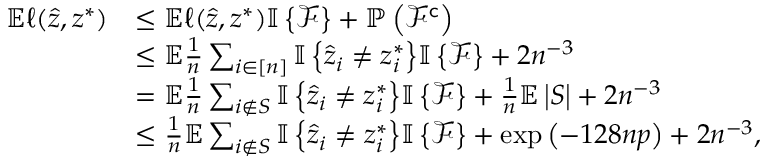Convert formula to latex. <formula><loc_0><loc_0><loc_500><loc_500>\begin{array} { r l } { \mathbb { E } \ell ( \hat { z } , z ^ { * } ) } & { \leq \mathbb { E } \ell ( \hat { z } , z ^ { * } ) { \mathbb { I } \left \{ { \mathcal { F } } \right \} } + \mathbb { P } \left ( \mathcal { F } ^ { c } \right ) } \\ & { \leq \mathbb { E } \frac { 1 } { n } \sum _ { i \in [ n ] } { \mathbb { I } \left \{ { \hat { z } _ { i } \neq z _ { i } ^ { * } } \right \} } { \mathbb { I } \left \{ { \mathcal { F } } \right \} } + 2 n ^ { - 3 } } \\ & { = \mathbb { E } \frac { 1 } { n } \sum _ { i \notin S } { \mathbb { I } \left \{ { \hat { z } _ { i } \neq z _ { i } ^ { * } } \right \} } { \mathbb { I } \left \{ { \mathcal { F } } \right \} } + \frac { 1 } { n } \mathbb { E } \left | S \right | + 2 n ^ { - 3 } } \\ & { \leq \frac { 1 } { n } \mathbb { E } \sum _ { i \notin S } { \mathbb { I } \left \{ { \hat { z } _ { i } \neq z _ { i } ^ { * } } \right \} } { \mathbb { I } \left \{ { \mathcal { F } } \right \} } + \exp \left ( - 1 2 8 n p \right ) + 2 n ^ { - 3 } , } \end{array}</formula> 